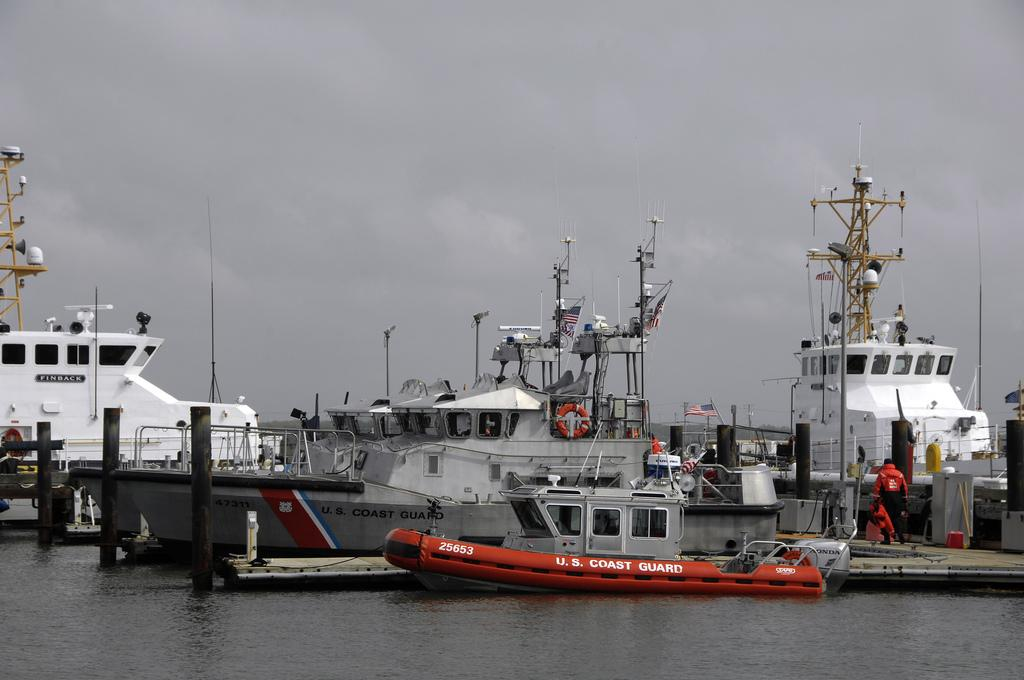What can be seen in the foreground of the picture? There is water in the foreground of the picture. What is located in the center of the picture? There are boats and a flag in the center of the picture. Can you describe the person in the center of the picture? There is a person in the center of the picture. What is the condition of the sky in the image? The sky is cloudy in the image. What type of chain is the person wearing in the image? There is no chain visible on the person in the image. What kind of jewel can be seen on the boats in the image? There are no jewels present on the boats in the image. 